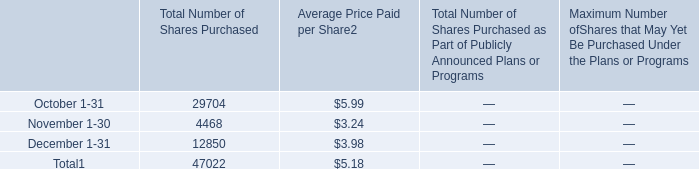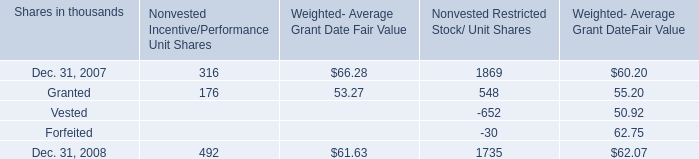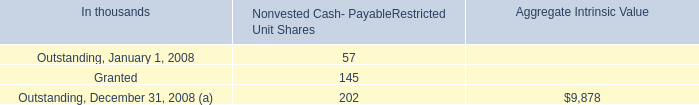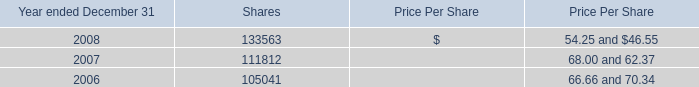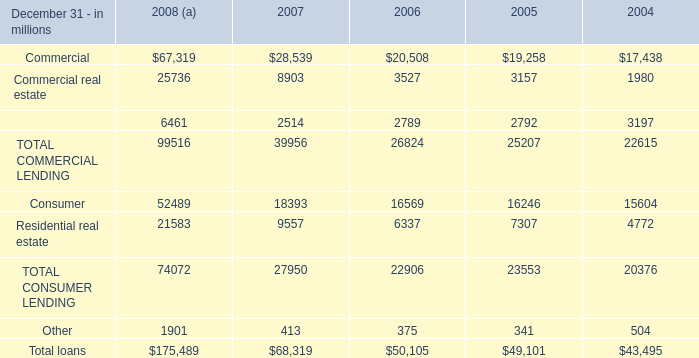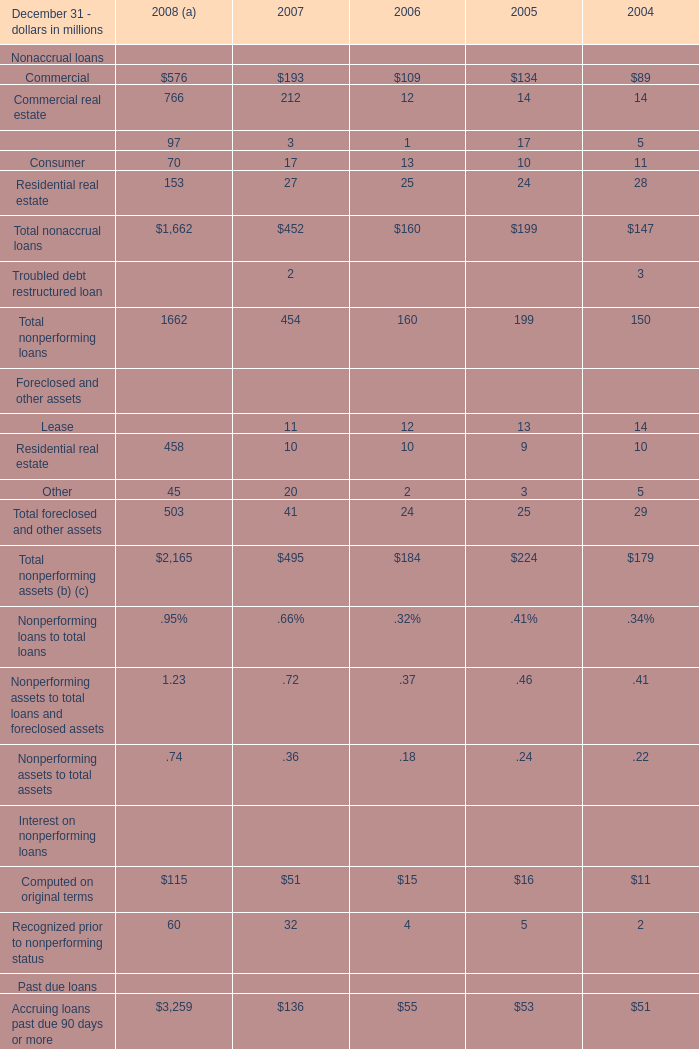Does the value of Equipment lease financing in 2007 greater than that in 2006? 
Answer: No. 